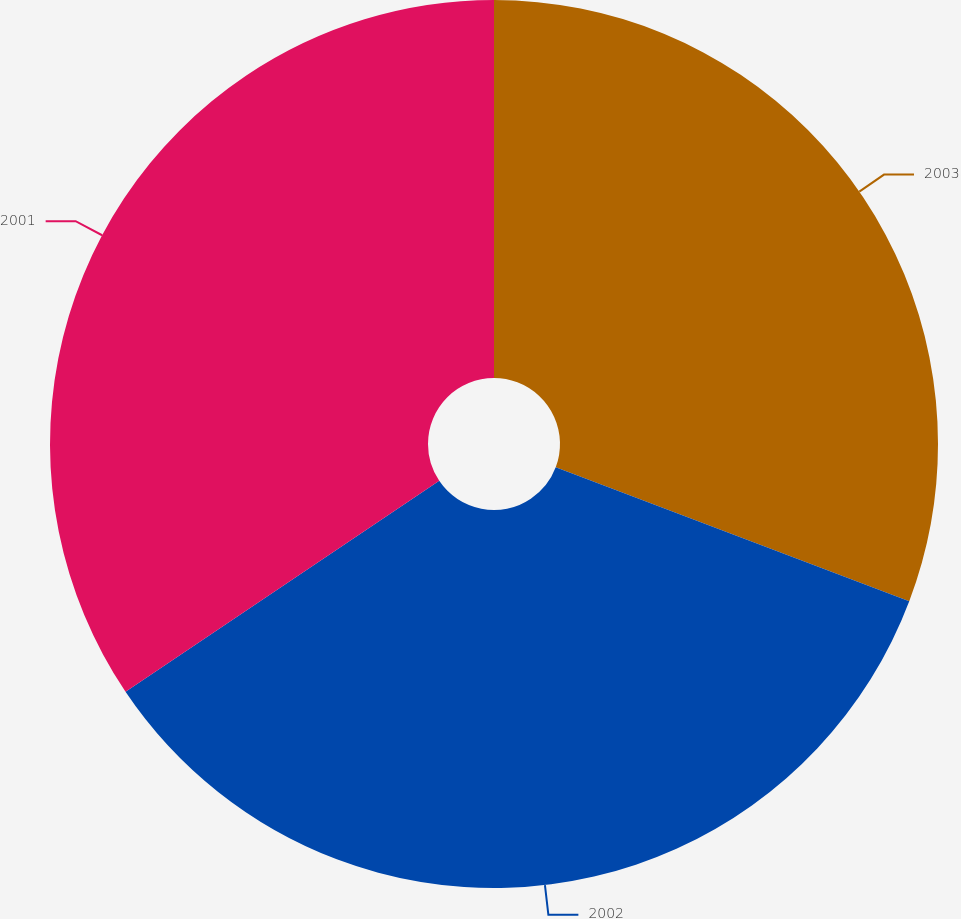<chart> <loc_0><loc_0><loc_500><loc_500><pie_chart><fcel>2003<fcel>2002<fcel>2001<nl><fcel>30.76%<fcel>34.82%<fcel>34.42%<nl></chart> 